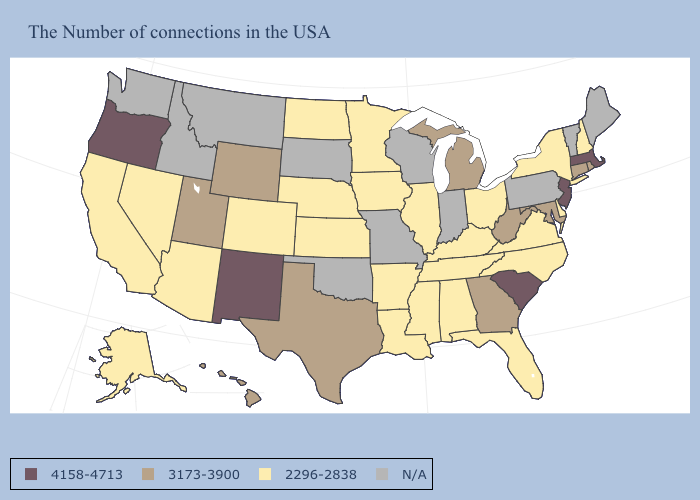Does Oregon have the highest value in the USA?
Concise answer only. Yes. What is the value of Wisconsin?
Short answer required. N/A. What is the value of Kentucky?
Concise answer only. 2296-2838. What is the highest value in the South ?
Concise answer only. 4158-4713. Which states have the lowest value in the Northeast?
Answer briefly. New Hampshire, New York. What is the lowest value in states that border North Carolina?
Answer briefly. 2296-2838. Which states have the lowest value in the USA?
Answer briefly. New Hampshire, New York, Delaware, Virginia, North Carolina, Ohio, Florida, Kentucky, Alabama, Tennessee, Illinois, Mississippi, Louisiana, Arkansas, Minnesota, Iowa, Kansas, Nebraska, North Dakota, Colorado, Arizona, Nevada, California, Alaska. Does Ohio have the lowest value in the USA?
Give a very brief answer. Yes. Name the states that have a value in the range 4158-4713?
Keep it brief. Massachusetts, New Jersey, South Carolina, New Mexico, Oregon. Does the map have missing data?
Answer briefly. Yes. Does Nevada have the highest value in the USA?
Be succinct. No. What is the value of Pennsylvania?
Be succinct. N/A. Does Massachusetts have the lowest value in the Northeast?
Quick response, please. No. What is the lowest value in the West?
Be succinct. 2296-2838. Does the map have missing data?
Short answer required. Yes. 